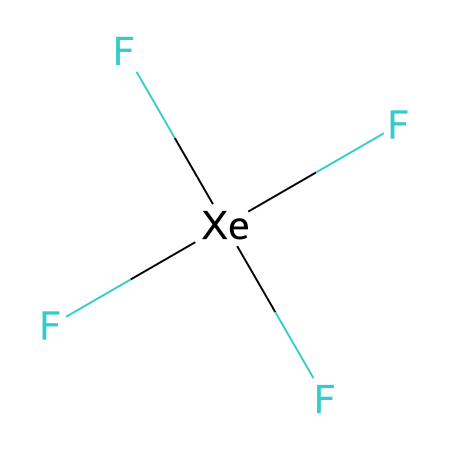What is the central atom in xenon tetrafluoride? The central atom is found by identifying the element in the center of the structure, which is xenon, as indicated by the surrounding fluorine atoms.
Answer: xenon How many fluorine atoms are bonded to xenon in this compound? By examining the structure, there are four fluorine atoms indicated by the four bonds to xenon.
Answer: four What is the molecular geometry of xenon tetrafluoride? The molecular geometry can be determined by the arrangement of the four fluorine atoms around the central xenon atom, which forms a square planar shape due to the pairing of electrons.
Answer: square planar Does xenon tetrafluoride exhibit hypervalency? Hypervalency occurs when an atom can have more than four bonds. In xenon tetrafluoride, xenon forms four bonds to fluorine, utilizing d orbitals, confirming hypervalency.
Answer: yes What is the hybridization of the central xenon atom in this compound? The hybridization can be determined by observing the number of bond pairs; with four fluorine surrounds, the hybridization is sp3d, indicating five orbitals are involved.
Answer: sp3d How do the lone pairs on xenon affect its molecular geometry? Xenon tetrafluoride has no lone pairs on xenon, which contributes to the ideal square planar geometry since all positions around xenon are occupied by bonding pairs.
Answer: none 